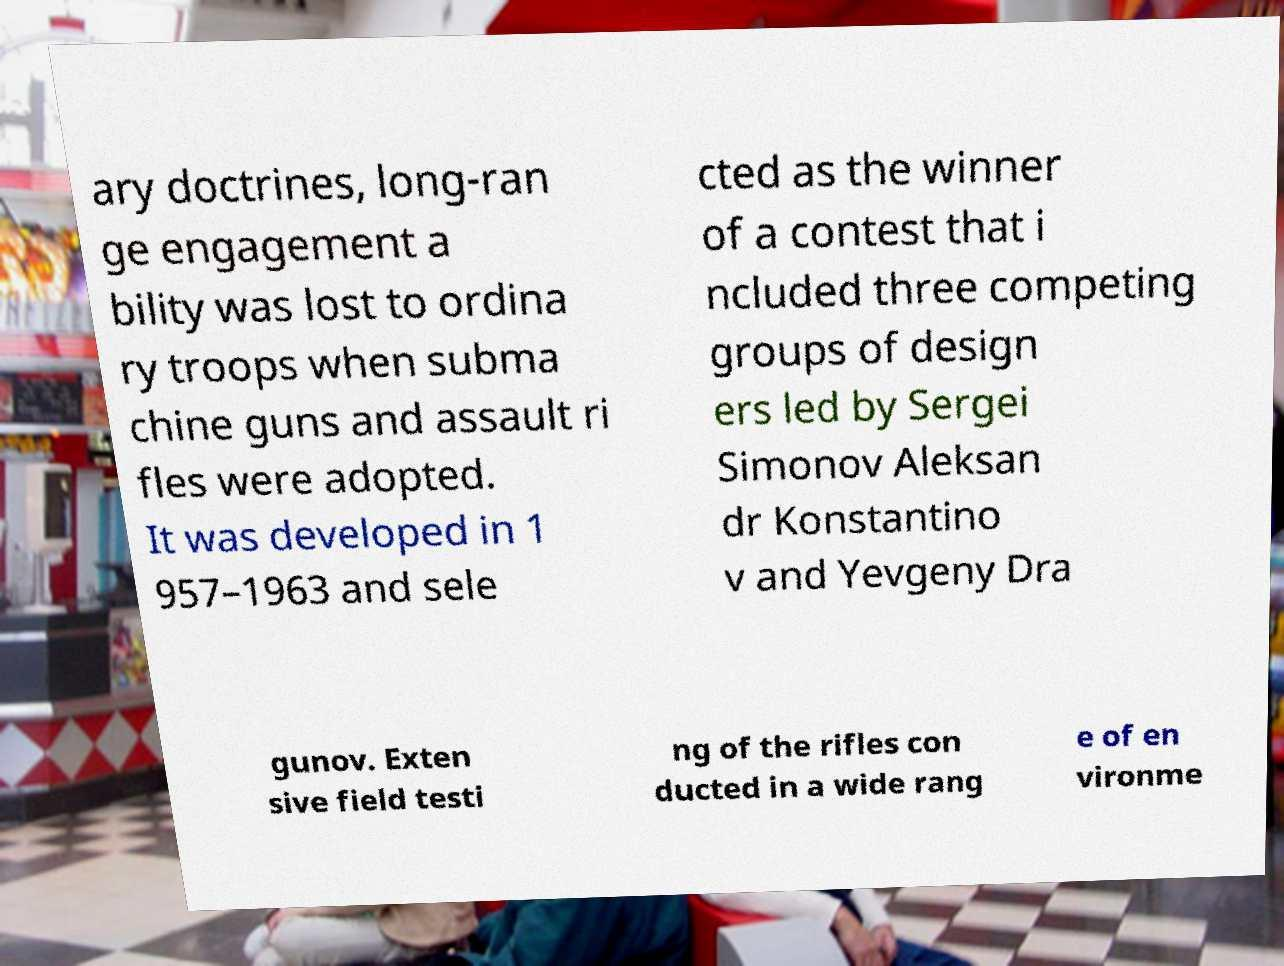There's text embedded in this image that I need extracted. Can you transcribe it verbatim? ary doctrines, long-ran ge engagement a bility was lost to ordina ry troops when subma chine guns and assault ri fles were adopted. It was developed in 1 957–1963 and sele cted as the winner of a contest that i ncluded three competing groups of design ers led by Sergei Simonov Aleksan dr Konstantino v and Yevgeny Dra gunov. Exten sive field testi ng of the rifles con ducted in a wide rang e of en vironme 